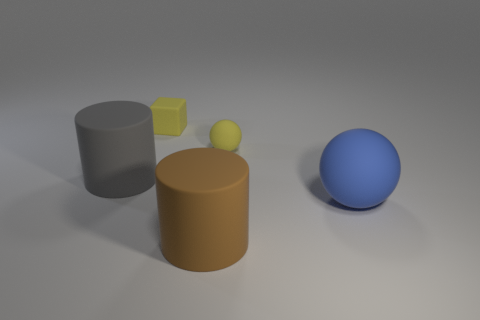Add 3 large blue balls. How many objects exist? 8 Subtract all balls. How many objects are left? 3 Subtract all small rubber cubes. Subtract all large rubber things. How many objects are left? 1 Add 3 yellow matte objects. How many yellow matte objects are left? 5 Add 1 small yellow matte blocks. How many small yellow matte blocks exist? 2 Subtract 0 brown spheres. How many objects are left? 5 